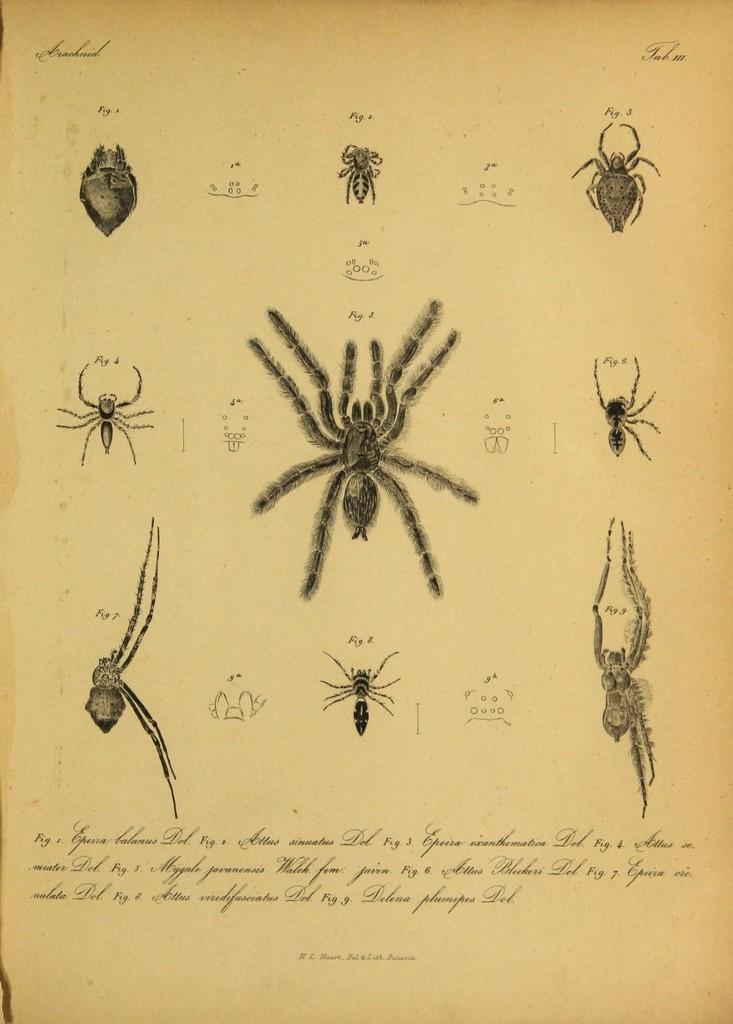What is present on the paper in the image? There is a spider and insects on the paper in the image. Is there any text on the paper? Yes, there is writing on the paper. What type of crow can be seen cooking on the side of the paper? There is no crow or cooking activity present in the image. 